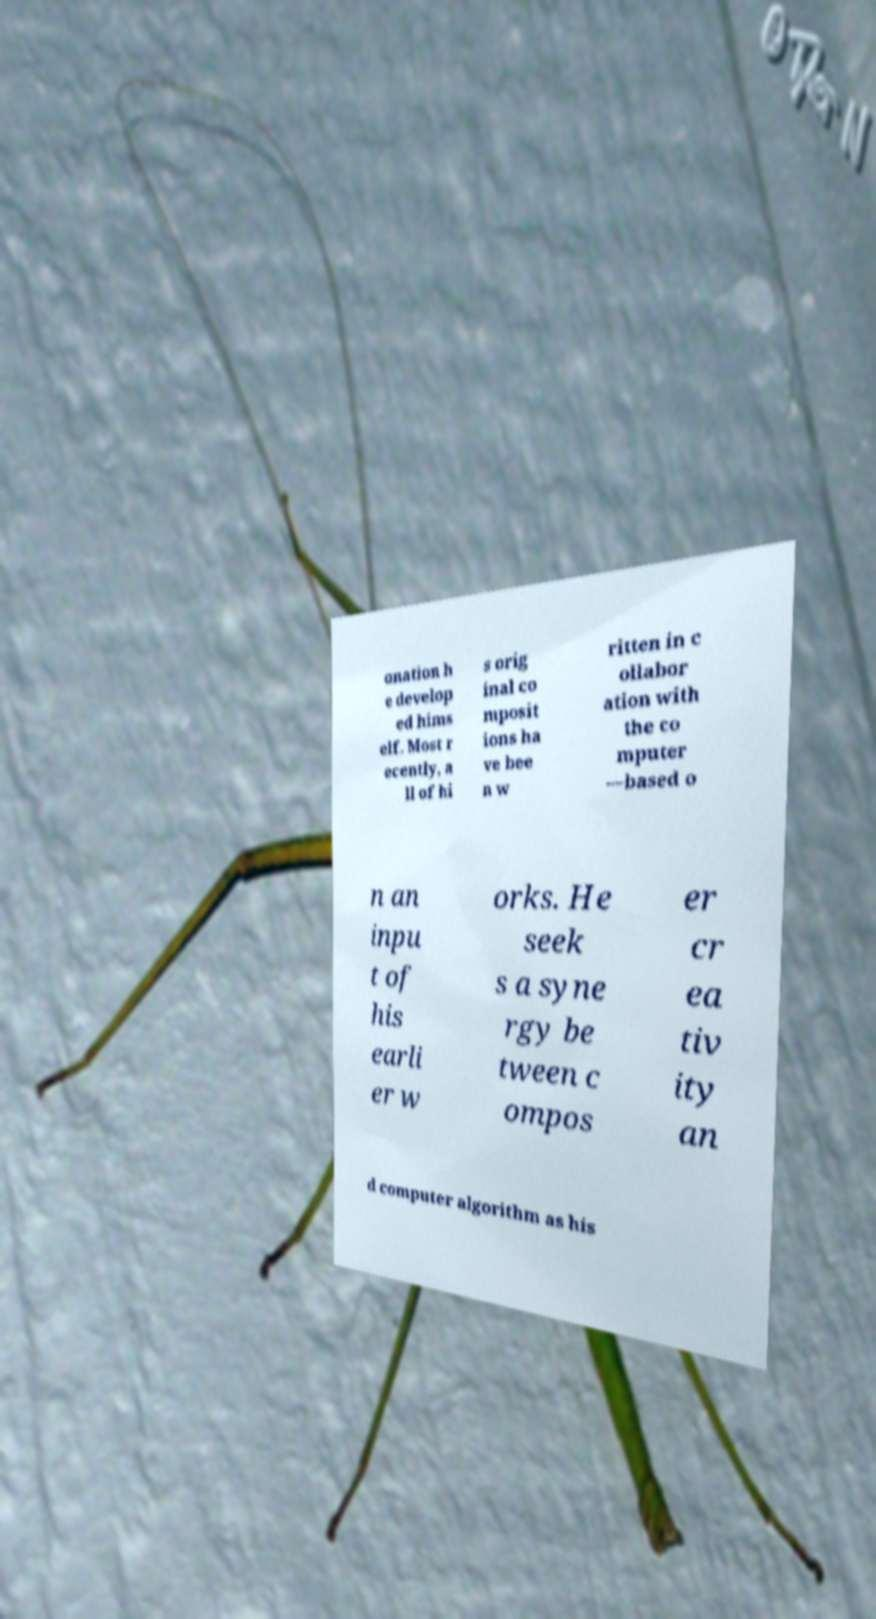Could you assist in decoding the text presented in this image and type it out clearly? onation h e develop ed hims elf. Most r ecently, a ll of hi s orig inal co mposit ions ha ve bee n w ritten in c ollabor ation with the co mputer —based o n an inpu t of his earli er w orks. He seek s a syne rgy be tween c ompos er cr ea tiv ity an d computer algorithm as his 